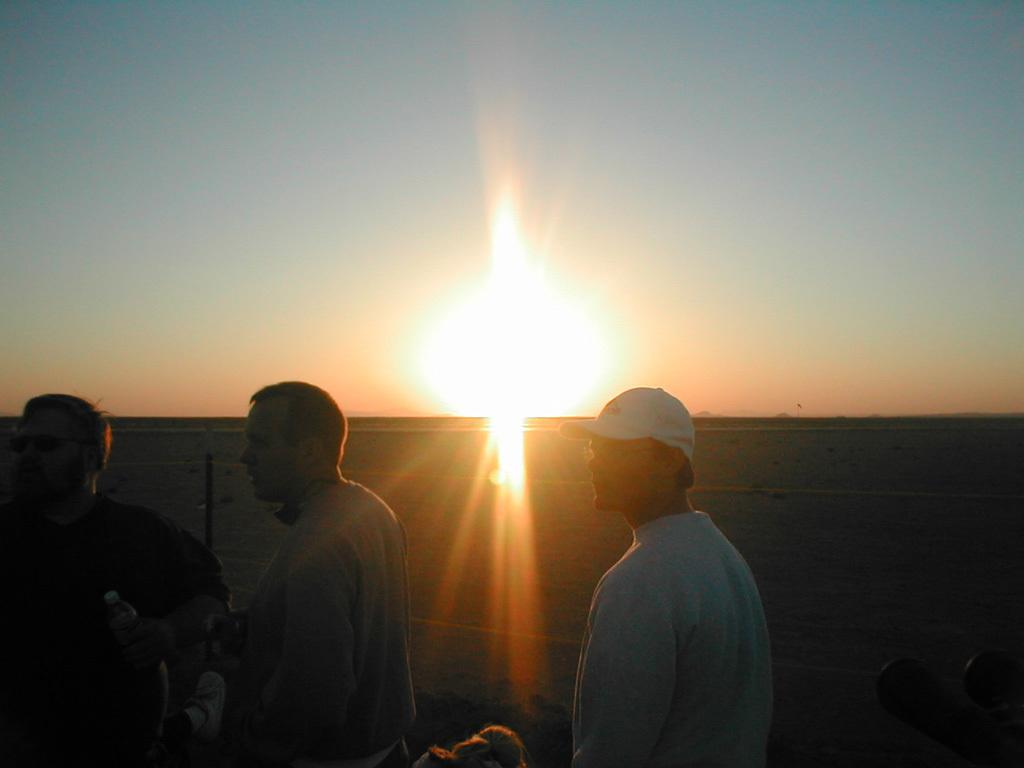Who or what can be seen in the image? There are people in the image. What type of surface is visible in the background of the image? There is ground visible in the background of the image. What part of the natural environment is visible in the image? The sky is visible in the background of the image. How many stones can be seen whistling in the image? There are no stones or whistling sounds present in the image. Can you spot any ants in the image? There are no ants visible in the image. 